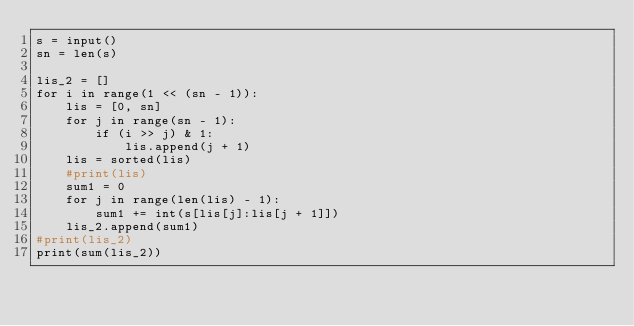Convert code to text. <code><loc_0><loc_0><loc_500><loc_500><_Python_>s = input()
sn = len(s)

lis_2 = []
for i in range(1 << (sn - 1)):
    lis = [0, sn]
    for j in range(sn - 1):
        if (i >> j) & 1:
            lis.append(j + 1)
    lis = sorted(lis)
    #print(lis)
    sum1 = 0
    for j in range(len(lis) - 1):
        sum1 += int(s[lis[j]:lis[j + 1]])
    lis_2.append(sum1)
#print(lis_2)
print(sum(lis_2))
</code> 